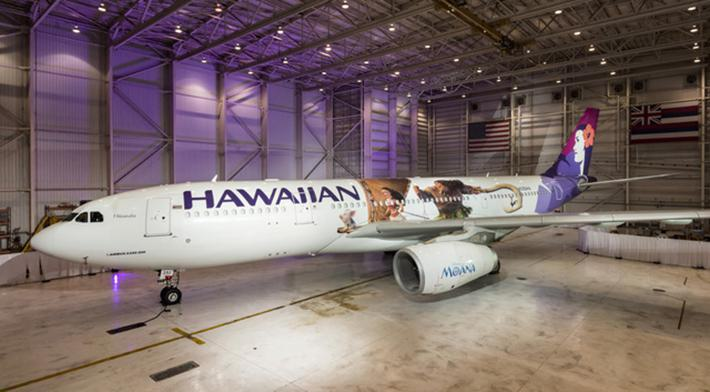What details can be observed about the airplane’s livery? The airplane in the image features a distinctive livery with the word 'Hawaiian' written prominently along its fuselage, accompanied by an image of figures enjoying various activities. The livery represents scenic elements and leisure activities associated with Hawaii, enhancing the airline's branding. 